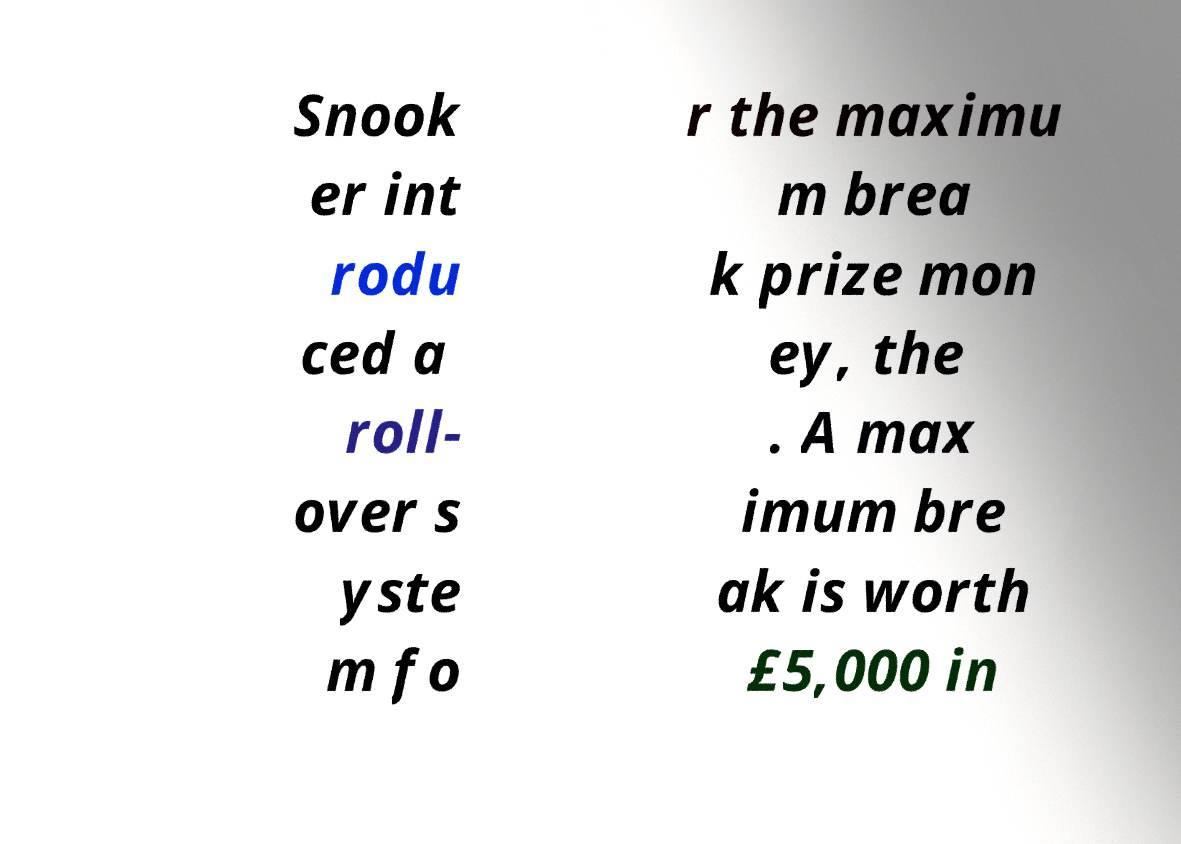I need the written content from this picture converted into text. Can you do that? Snook er int rodu ced a roll- over s yste m fo r the maximu m brea k prize mon ey, the . A max imum bre ak is worth £5,000 in 